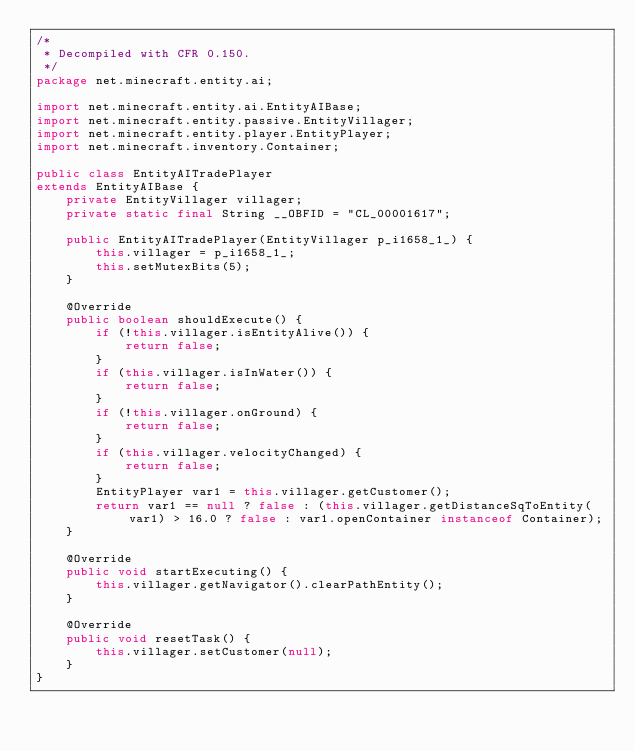Convert code to text. <code><loc_0><loc_0><loc_500><loc_500><_Java_>/*
 * Decompiled with CFR 0.150.
 */
package net.minecraft.entity.ai;

import net.minecraft.entity.ai.EntityAIBase;
import net.minecraft.entity.passive.EntityVillager;
import net.minecraft.entity.player.EntityPlayer;
import net.minecraft.inventory.Container;

public class EntityAITradePlayer
extends EntityAIBase {
    private EntityVillager villager;
    private static final String __OBFID = "CL_00001617";

    public EntityAITradePlayer(EntityVillager p_i1658_1_) {
        this.villager = p_i1658_1_;
        this.setMutexBits(5);
    }

    @Override
    public boolean shouldExecute() {
        if (!this.villager.isEntityAlive()) {
            return false;
        }
        if (this.villager.isInWater()) {
            return false;
        }
        if (!this.villager.onGround) {
            return false;
        }
        if (this.villager.velocityChanged) {
            return false;
        }
        EntityPlayer var1 = this.villager.getCustomer();
        return var1 == null ? false : (this.villager.getDistanceSqToEntity(var1) > 16.0 ? false : var1.openContainer instanceof Container);
    }

    @Override
    public void startExecuting() {
        this.villager.getNavigator().clearPathEntity();
    }

    @Override
    public void resetTask() {
        this.villager.setCustomer(null);
    }
}

</code> 